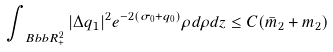<formula> <loc_0><loc_0><loc_500><loc_500>\int _ { \ B b b R _ { + } ^ { 2 } } | \Delta q _ { 1 } | ^ { 2 } e ^ { - 2 ( \sigma _ { 0 } + q _ { 0 } ) } \rho d \rho d z \leq C ( \bar { m } _ { 2 } + m _ { 2 } )</formula> 